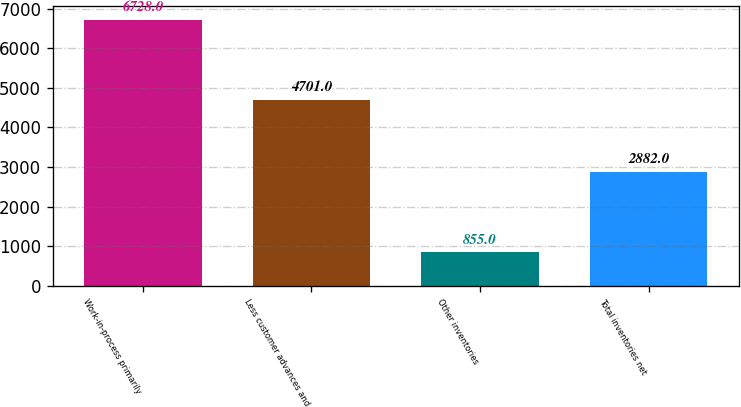Convert chart. <chart><loc_0><loc_0><loc_500><loc_500><bar_chart><fcel>Work-in-process primarily<fcel>Less customer advances and<fcel>Other inventories<fcel>Total inventories net<nl><fcel>6728<fcel>4701<fcel>855<fcel>2882<nl></chart> 